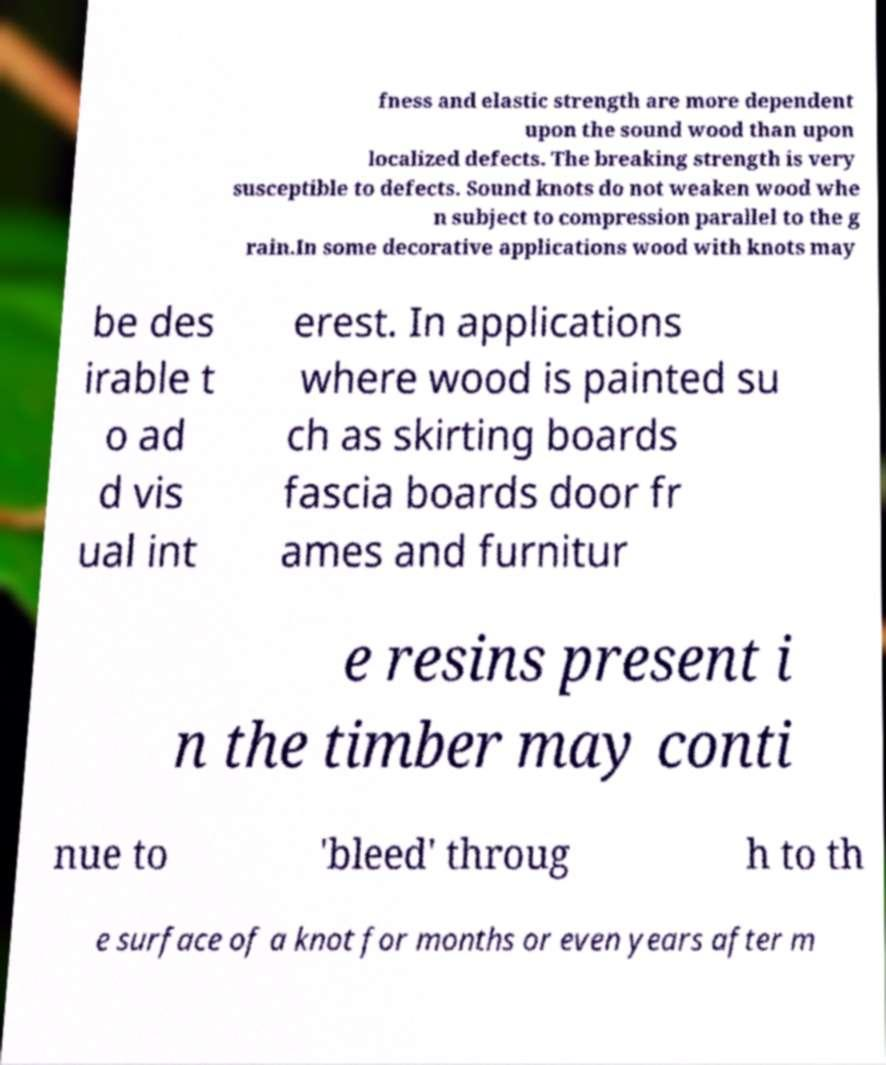I need the written content from this picture converted into text. Can you do that? fness and elastic strength are more dependent upon the sound wood than upon localized defects. The breaking strength is very susceptible to defects. Sound knots do not weaken wood whe n subject to compression parallel to the g rain.In some decorative applications wood with knots may be des irable t o ad d vis ual int erest. In applications where wood is painted su ch as skirting boards fascia boards door fr ames and furnitur e resins present i n the timber may conti nue to 'bleed' throug h to th e surface of a knot for months or even years after m 